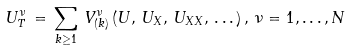<formula> <loc_0><loc_0><loc_500><loc_500>U ^ { \nu } _ { T } \, = \, \sum _ { k \geq 1 } \, V ^ { \nu } _ { ( k ) } \, ( { U } , \, { U } _ { X } , \, { U } _ { X X } , \, \dots \, ) \, , \, \nu = 1 , \dots , N</formula> 